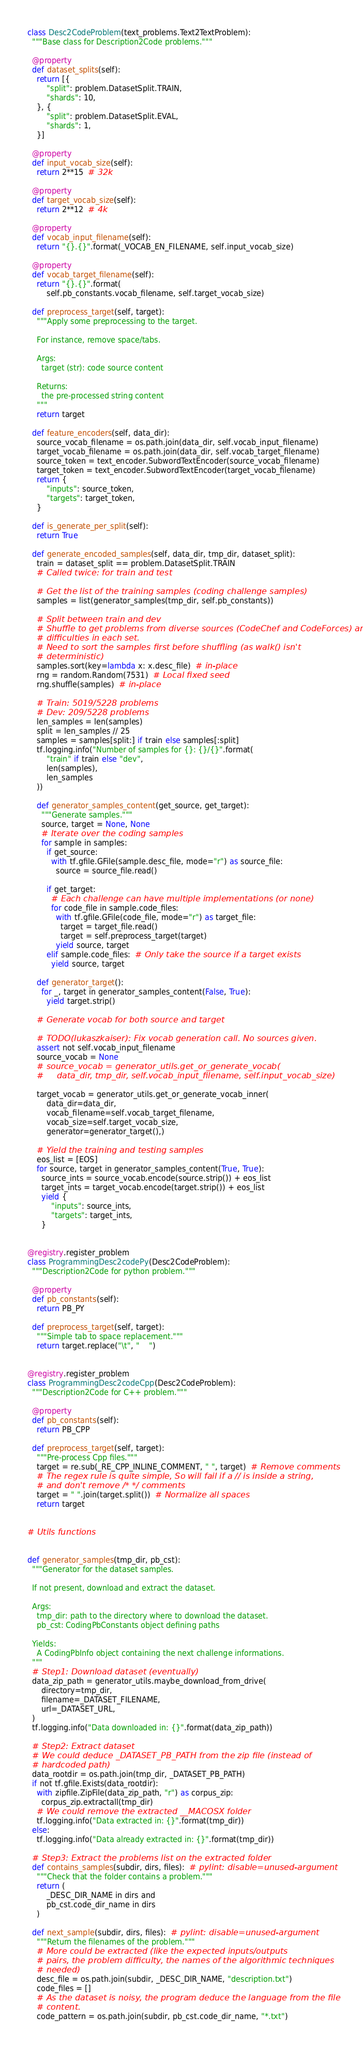<code> <loc_0><loc_0><loc_500><loc_500><_Python_>

class Desc2CodeProblem(text_problems.Text2TextProblem):
  """Base class for Description2Code problems."""

  @property
  def dataset_splits(self):
    return [{
        "split": problem.DatasetSplit.TRAIN,
        "shards": 10,
    }, {
        "split": problem.DatasetSplit.EVAL,
        "shards": 1,
    }]

  @property
  def input_vocab_size(self):
    return 2**15  # 32k

  @property
  def target_vocab_size(self):
    return 2**12  # 4k

  @property
  def vocab_input_filename(self):
    return "{}.{}".format(_VOCAB_EN_FILENAME, self.input_vocab_size)

  @property
  def vocab_target_filename(self):
    return "{}.{}".format(
        self.pb_constants.vocab_filename, self.target_vocab_size)

  def preprocess_target(self, target):
    """Apply some preprocessing to the target.

    For instance, remove space/tabs.

    Args:
      target (str): code source content

    Returns:
      the pre-processed string content
    """
    return target

  def feature_encoders(self, data_dir):
    source_vocab_filename = os.path.join(data_dir, self.vocab_input_filename)
    target_vocab_filename = os.path.join(data_dir, self.vocab_target_filename)
    source_token = text_encoder.SubwordTextEncoder(source_vocab_filename)
    target_token = text_encoder.SubwordTextEncoder(target_vocab_filename)
    return {
        "inputs": source_token,
        "targets": target_token,
    }

  def is_generate_per_split(self):
    return True

  def generate_encoded_samples(self, data_dir, tmp_dir, dataset_split):
    train = dataset_split == problem.DatasetSplit.TRAIN
    # Called twice: for train and test

    # Get the list of the training samples (coding challenge samples)
    samples = list(generator_samples(tmp_dir, self.pb_constants))

    # Split between train and dev
    # Shuffle to get problems from diverse sources (CodeChef and CodeForces) and
    # difficulties in each set.
    # Need to sort the samples first before shuffling (as walk() isn't
    # deterministic)
    samples.sort(key=lambda x: x.desc_file)  # in-place
    rng = random.Random(7531)  # Local fixed seed
    rng.shuffle(samples)  # in-place

    # Train: 5019/5228 problems
    # Dev: 209/5228 problems
    len_samples = len(samples)
    split = len_samples // 25
    samples = samples[split:] if train else samples[:split]
    tf.logging.info("Number of samples for {}: {}/{}".format(
        "train" if train else "dev",
        len(samples),
        len_samples
    ))

    def generator_samples_content(get_source, get_target):
      """Generate samples."""
      source, target = None, None
      # Iterate over the coding samples
      for sample in samples:
        if get_source:
          with tf.gfile.GFile(sample.desc_file, mode="r") as source_file:
            source = source_file.read()

        if get_target:
          # Each challenge can have multiple implementations (or none)
          for code_file in sample.code_files:
            with tf.gfile.GFile(code_file, mode="r") as target_file:
              target = target_file.read()
              target = self.preprocess_target(target)
            yield source, target
        elif sample.code_files:  # Only take the source if a target exists
          yield source, target

    def generator_target():
      for _, target in generator_samples_content(False, True):
        yield target.strip()

    # Generate vocab for both source and target

    # TODO(lukaszkaiser): Fix vocab generation call. No sources given.
    assert not self.vocab_input_filename
    source_vocab = None
    # source_vocab = generator_utils.get_or_generate_vocab(
    #     data_dir, tmp_dir, self.vocab_input_filename, self.input_vocab_size)

    target_vocab = generator_utils.get_or_generate_vocab_inner(
        data_dir=data_dir,
        vocab_filename=self.vocab_target_filename,
        vocab_size=self.target_vocab_size,
        generator=generator_target(),)

    # Yield the training and testing samples
    eos_list = [EOS]
    for source, target in generator_samples_content(True, True):
      source_ints = source_vocab.encode(source.strip()) + eos_list
      target_ints = target_vocab.encode(target.strip()) + eos_list
      yield {
          "inputs": source_ints,
          "targets": target_ints,
      }


@registry.register_problem
class ProgrammingDesc2codePy(Desc2CodeProblem):
  """Description2Code for python problem."""

  @property
  def pb_constants(self):
    return PB_PY

  def preprocess_target(self, target):
    """Simple tab to space replacement."""
    return target.replace("\t", "    ")


@registry.register_problem
class ProgrammingDesc2codeCpp(Desc2CodeProblem):
  """Description2Code for C++ problem."""

  @property
  def pb_constants(self):
    return PB_CPP

  def preprocess_target(self, target):
    """Pre-process Cpp files."""
    target = re.sub(_RE_CPP_INLINE_COMMENT, " ", target)  # Remove comments
    # The regex rule is quite simple, So will fail if a // is inside a string,
    # and don't remove /* */ comments
    target = " ".join(target.split())  # Normalize all spaces
    return target


# Utils functions


def generator_samples(tmp_dir, pb_cst):
  """Generator for the dataset samples.

  If not present, download and extract the dataset.

  Args:
    tmp_dir: path to the directory where to download the dataset.
    pb_cst: CodingPbConstants object defining paths

  Yields:
    A CodingPbInfo object containing the next challenge informations.
  """
  # Step1: Download dataset (eventually)
  data_zip_path = generator_utils.maybe_download_from_drive(
      directory=tmp_dir,
      filename=_DATASET_FILENAME,
      url=_DATASET_URL,
  )
  tf.logging.info("Data downloaded in: {}".format(data_zip_path))

  # Step2: Extract dataset
  # We could deduce _DATASET_PB_PATH from the zip file (instead of
  # hardcoded path)
  data_rootdir = os.path.join(tmp_dir, _DATASET_PB_PATH)
  if not tf.gfile.Exists(data_rootdir):
    with zipfile.ZipFile(data_zip_path, "r") as corpus_zip:
      corpus_zip.extractall(tmp_dir)
    # We could remove the extracted __MACOSX folder
    tf.logging.info("Data extracted in: {}".format(tmp_dir))
  else:
    tf.logging.info("Data already extracted in: {}".format(tmp_dir))

  # Step3: Extract the problems list on the extracted folder
  def contains_samples(subdir, dirs, files):  # pylint: disable=unused-argument
    """Check that the folder contains a problem."""
    return (
        _DESC_DIR_NAME in dirs and
        pb_cst.code_dir_name in dirs
    )

  def next_sample(subdir, dirs, files):  # pylint: disable=unused-argument
    """Return the filenames of the problem."""
    # More could be extracted (like the expected inputs/outputs
    # pairs, the problem difficulty, the names of the algorithmic techniques
    # needed)
    desc_file = os.path.join(subdir, _DESC_DIR_NAME, "description.txt")
    code_files = []
    # As the dataset is noisy, the program deduce the language from the file
    # content.
    code_pattern = os.path.join(subdir, pb_cst.code_dir_name, "*.txt")</code> 